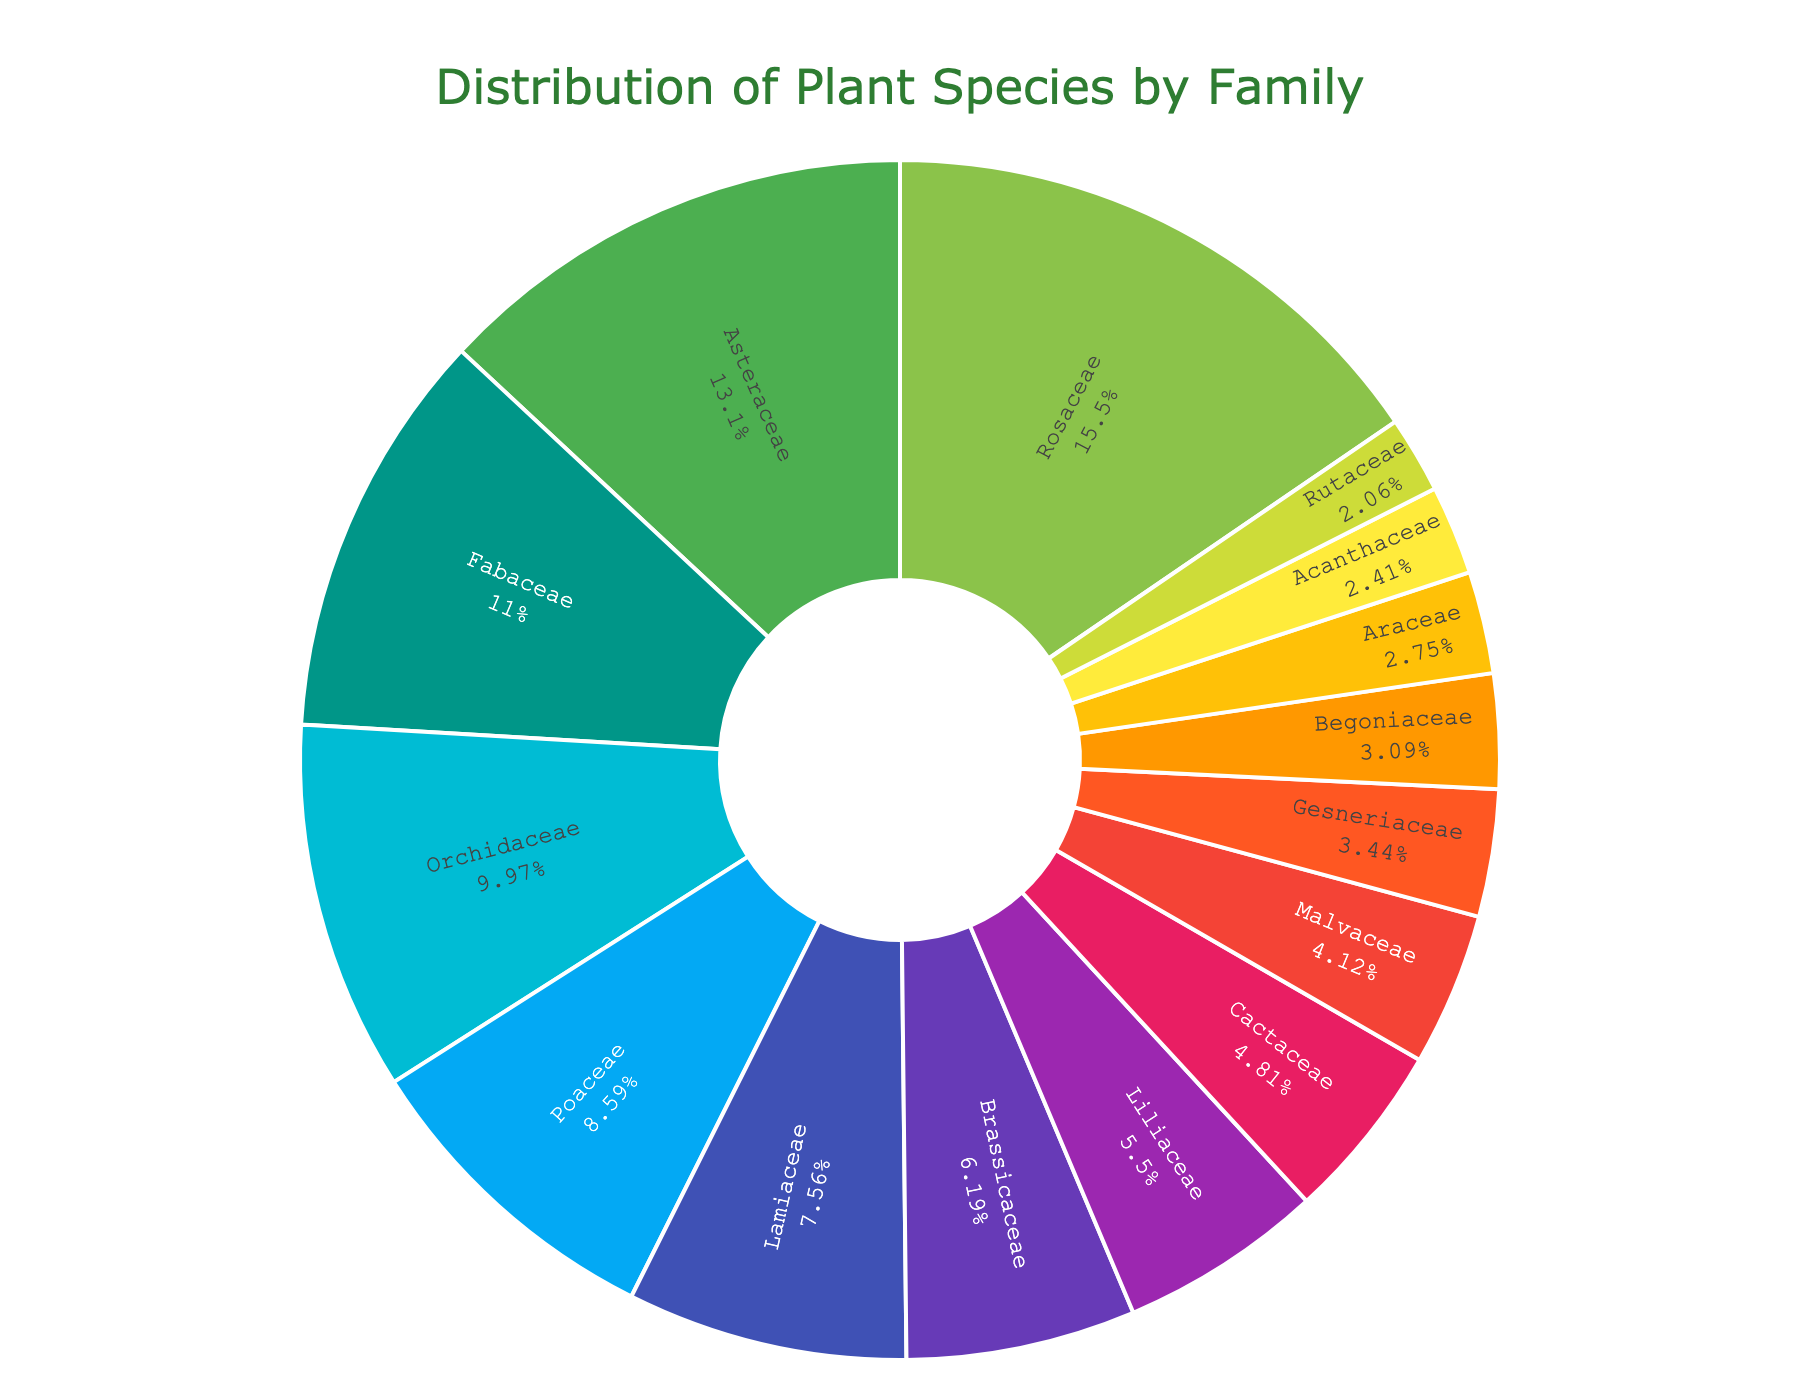Which plant family has the largest distribution in the botanical garden? Look at the chart and identify the segment with the largest portion. The Rosaceae family takes up the largest part of the pie chart.
Answer: Rosaceae What percentage of plant species does the Fabaceae family represent? Examine the labeled percentage on the pie chart for the Fabaceae family.
Answer: 13.8% Which has more plant species, Asteraceae or Poaceae? Compare the pie chart segments labeled Asteraceae and Poaceae and note their corresponding values. Asteraceae has 38 species, and Poaceae has 25 species.
Answer: Asteraceae What is the total number of plant species represented by Lamiaceae and Begoniaceae? Add the number of species for Lamiaceae (22) and Begoniaceae (9). The sum is 22 + 9 = 31.
Answer: 31 Which plant family constitutes approximately 7% of the total species in the garden? Find the segment of the pie chart labeled with around 7%. The Lamiaceae family has approximately 7% represented.
Answer: Lamiaceae What is the difference in species number between the family with the most species and the family with the least species? Identify the family with the most and the family with the least, then subtract their species numbers. The difference between Rosaceae (45) and Rutaceae (6) is 45 - 6 = 39.
Answer: 39 How many species in total are represented by families with less than 15 species? Add up the species numbers for families with less than 15 species: Cactaceae (14), Malvaceae (12), Gesneriaceae (10), Begoniaceae (9), Araceae (8), Acanthaceae (7), Rutaceae (6). The sum is 14 + 12 + 10 + 9 + 8 + 7 + 6 = 66.
Answer: 66 Which plant family is represented by a deep purple color? Describe the deep purple segment in the pie chart. The Cactaceae family is represented by deep purple.
Answer: Cactaceae If you group the species into two categories, monocots (Orchidaceae, Poaceae, Liliaceae, Araceae) and dicots (remaining families), which category has more species? Sum the species numbers for monocot families and dicot families. Monocots: Orchidaceae (29) + Poaceae (25) + Liliaceae (16) + Araceae (8) = 78. Dicots: Rosaceae (45) + Asteraceae (38) + Fabaceae (32) + Lamiaceae (22) + Brassicaceae (18) + Cactaceae (14) + Malvaceae (12) + Gesneriaceae (10) + Begoniaceae (9) + Acanthaceae (7) + Rutaceae (6) = 213. Dicots have more species.
Answer: Dicots 